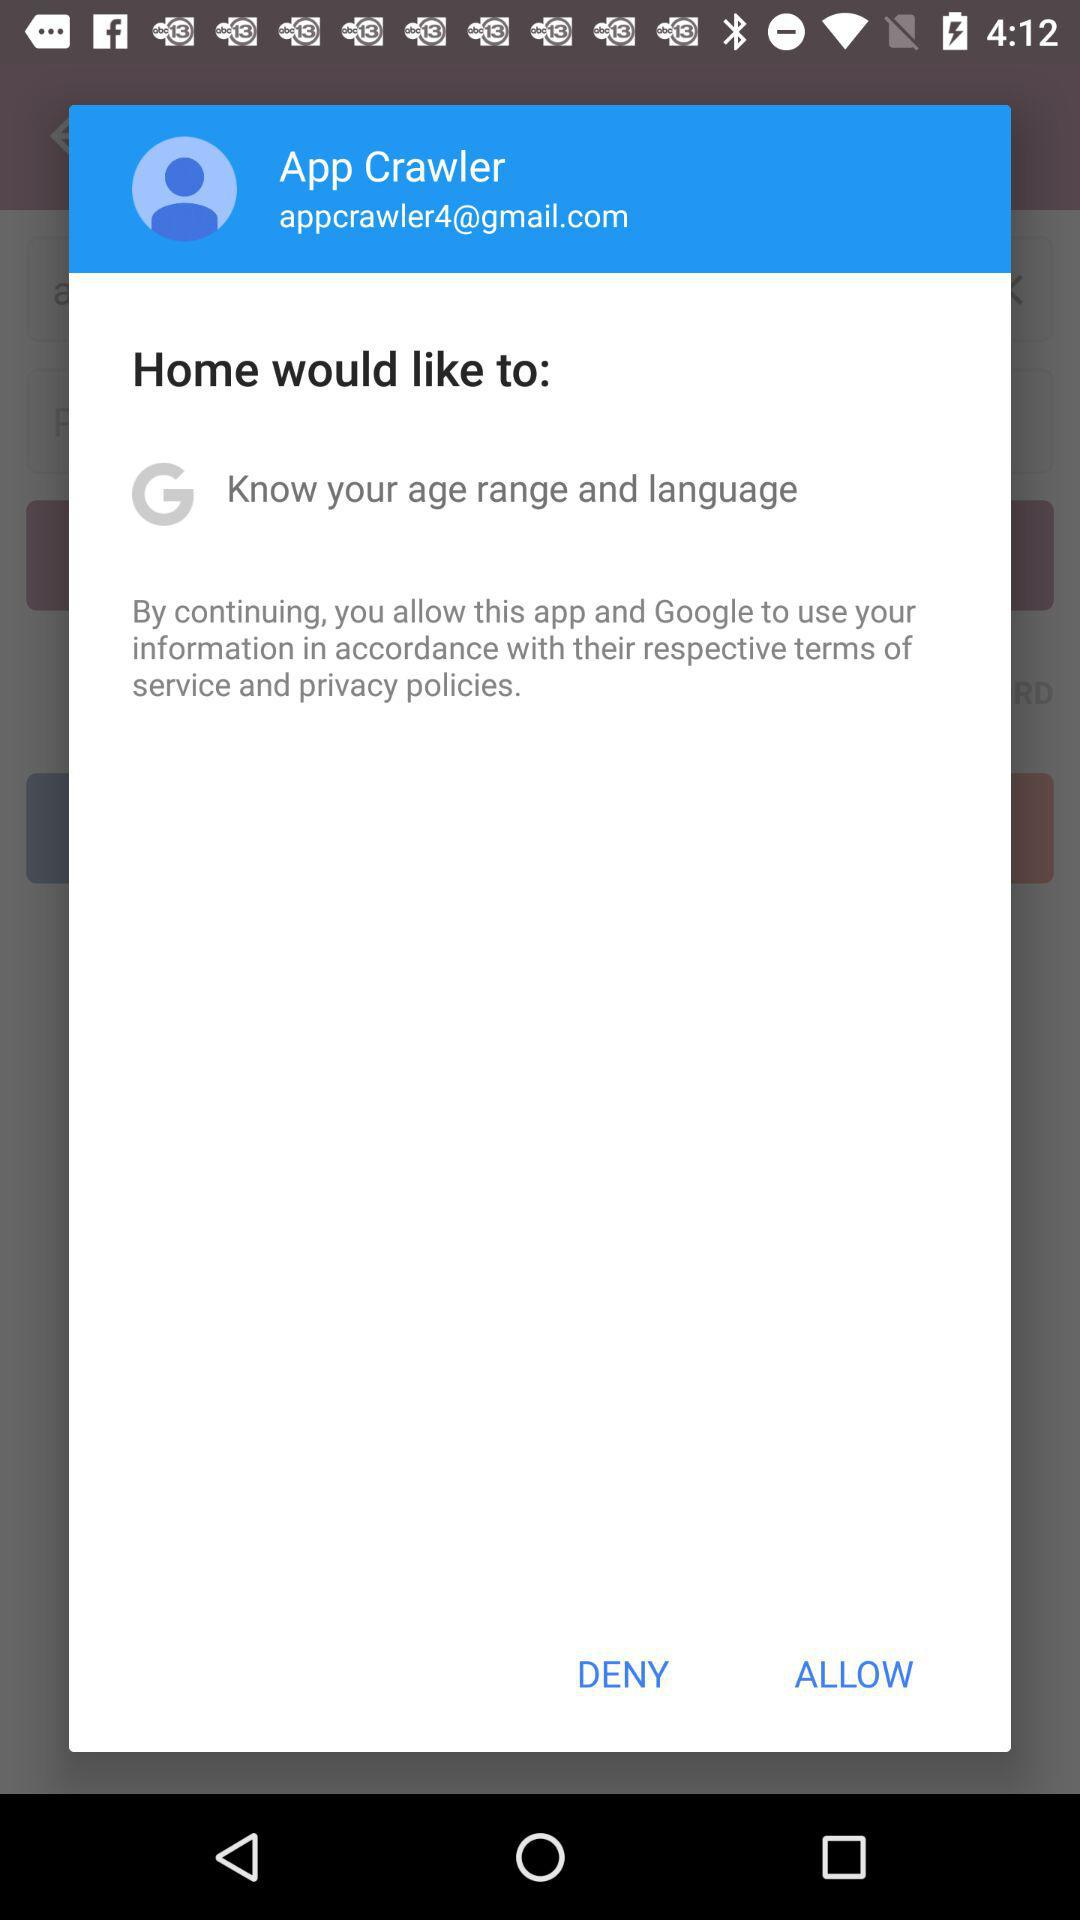What Gmail address is used? The used Gmail address is appcrawler4@gmail.com. 